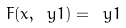<formula> <loc_0><loc_0><loc_500><loc_500>\ F ( x , \ y 1 ) = \ y 1</formula> 